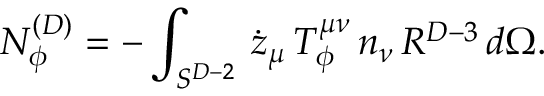Convert formula to latex. <formula><loc_0><loc_0><loc_500><loc_500>N _ { \phi } ^ { ( D ) } = - \int _ { S ^ { D - 2 } } \, \dot { z } _ { \mu } \, T _ { \phi } ^ { \mu \nu } \, n _ { \nu } \, R ^ { D - 3 } \, d \Omega .</formula> 